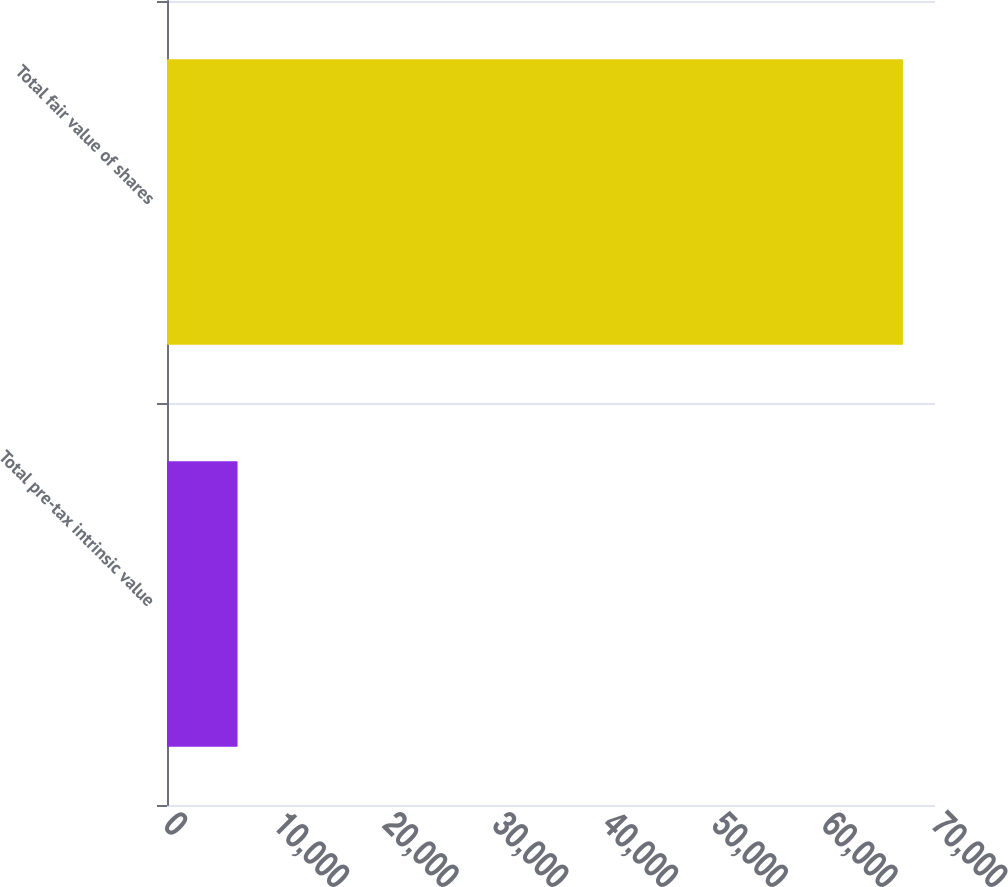<chart> <loc_0><loc_0><loc_500><loc_500><bar_chart><fcel>Total pre-tax intrinsic value<fcel>Total fair value of shares<nl><fcel>6429<fcel>67076<nl></chart> 